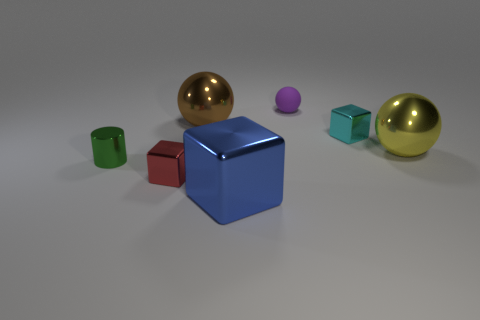Subtract all balls. How many objects are left? 4 Subtract 2 spheres. How many spheres are left? 1 Subtract all red cylinders. Subtract all blue cubes. How many cylinders are left? 1 Subtract all red spheres. How many purple cylinders are left? 0 Subtract all red cubes. Subtract all small cyan metal objects. How many objects are left? 5 Add 7 brown metallic things. How many brown metallic things are left? 8 Add 6 red metal blocks. How many red metal blocks exist? 7 Add 2 yellow metallic cylinders. How many objects exist? 9 Subtract all big spheres. How many spheres are left? 1 Subtract 0 purple cylinders. How many objects are left? 7 